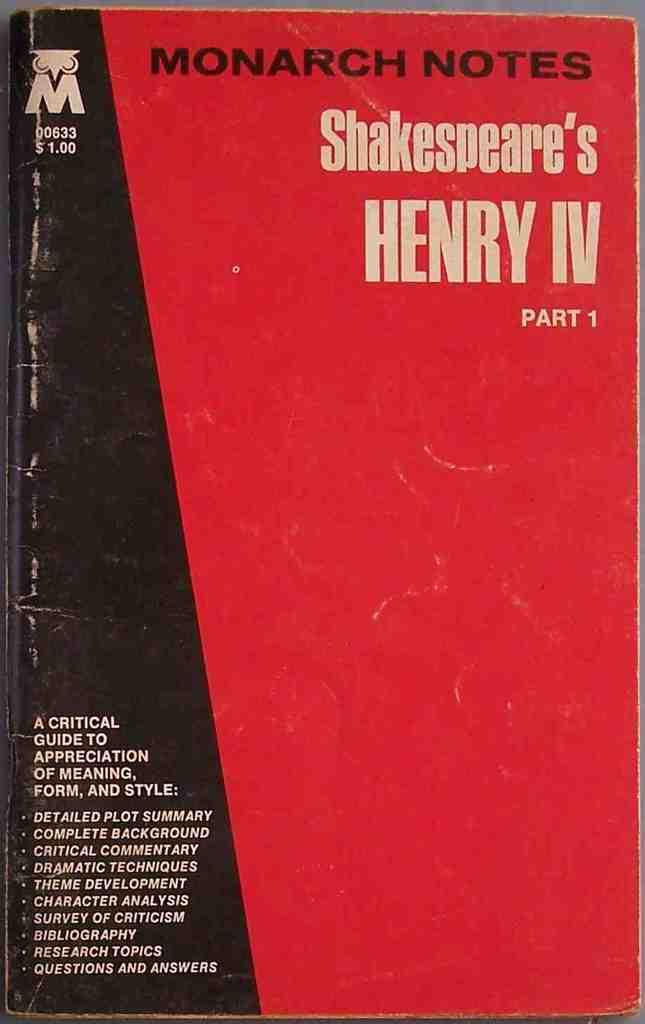<image>
Describe the image concisely. A red and black book is titled MONARCH NOTES Shakespeare's HENRY IV. 